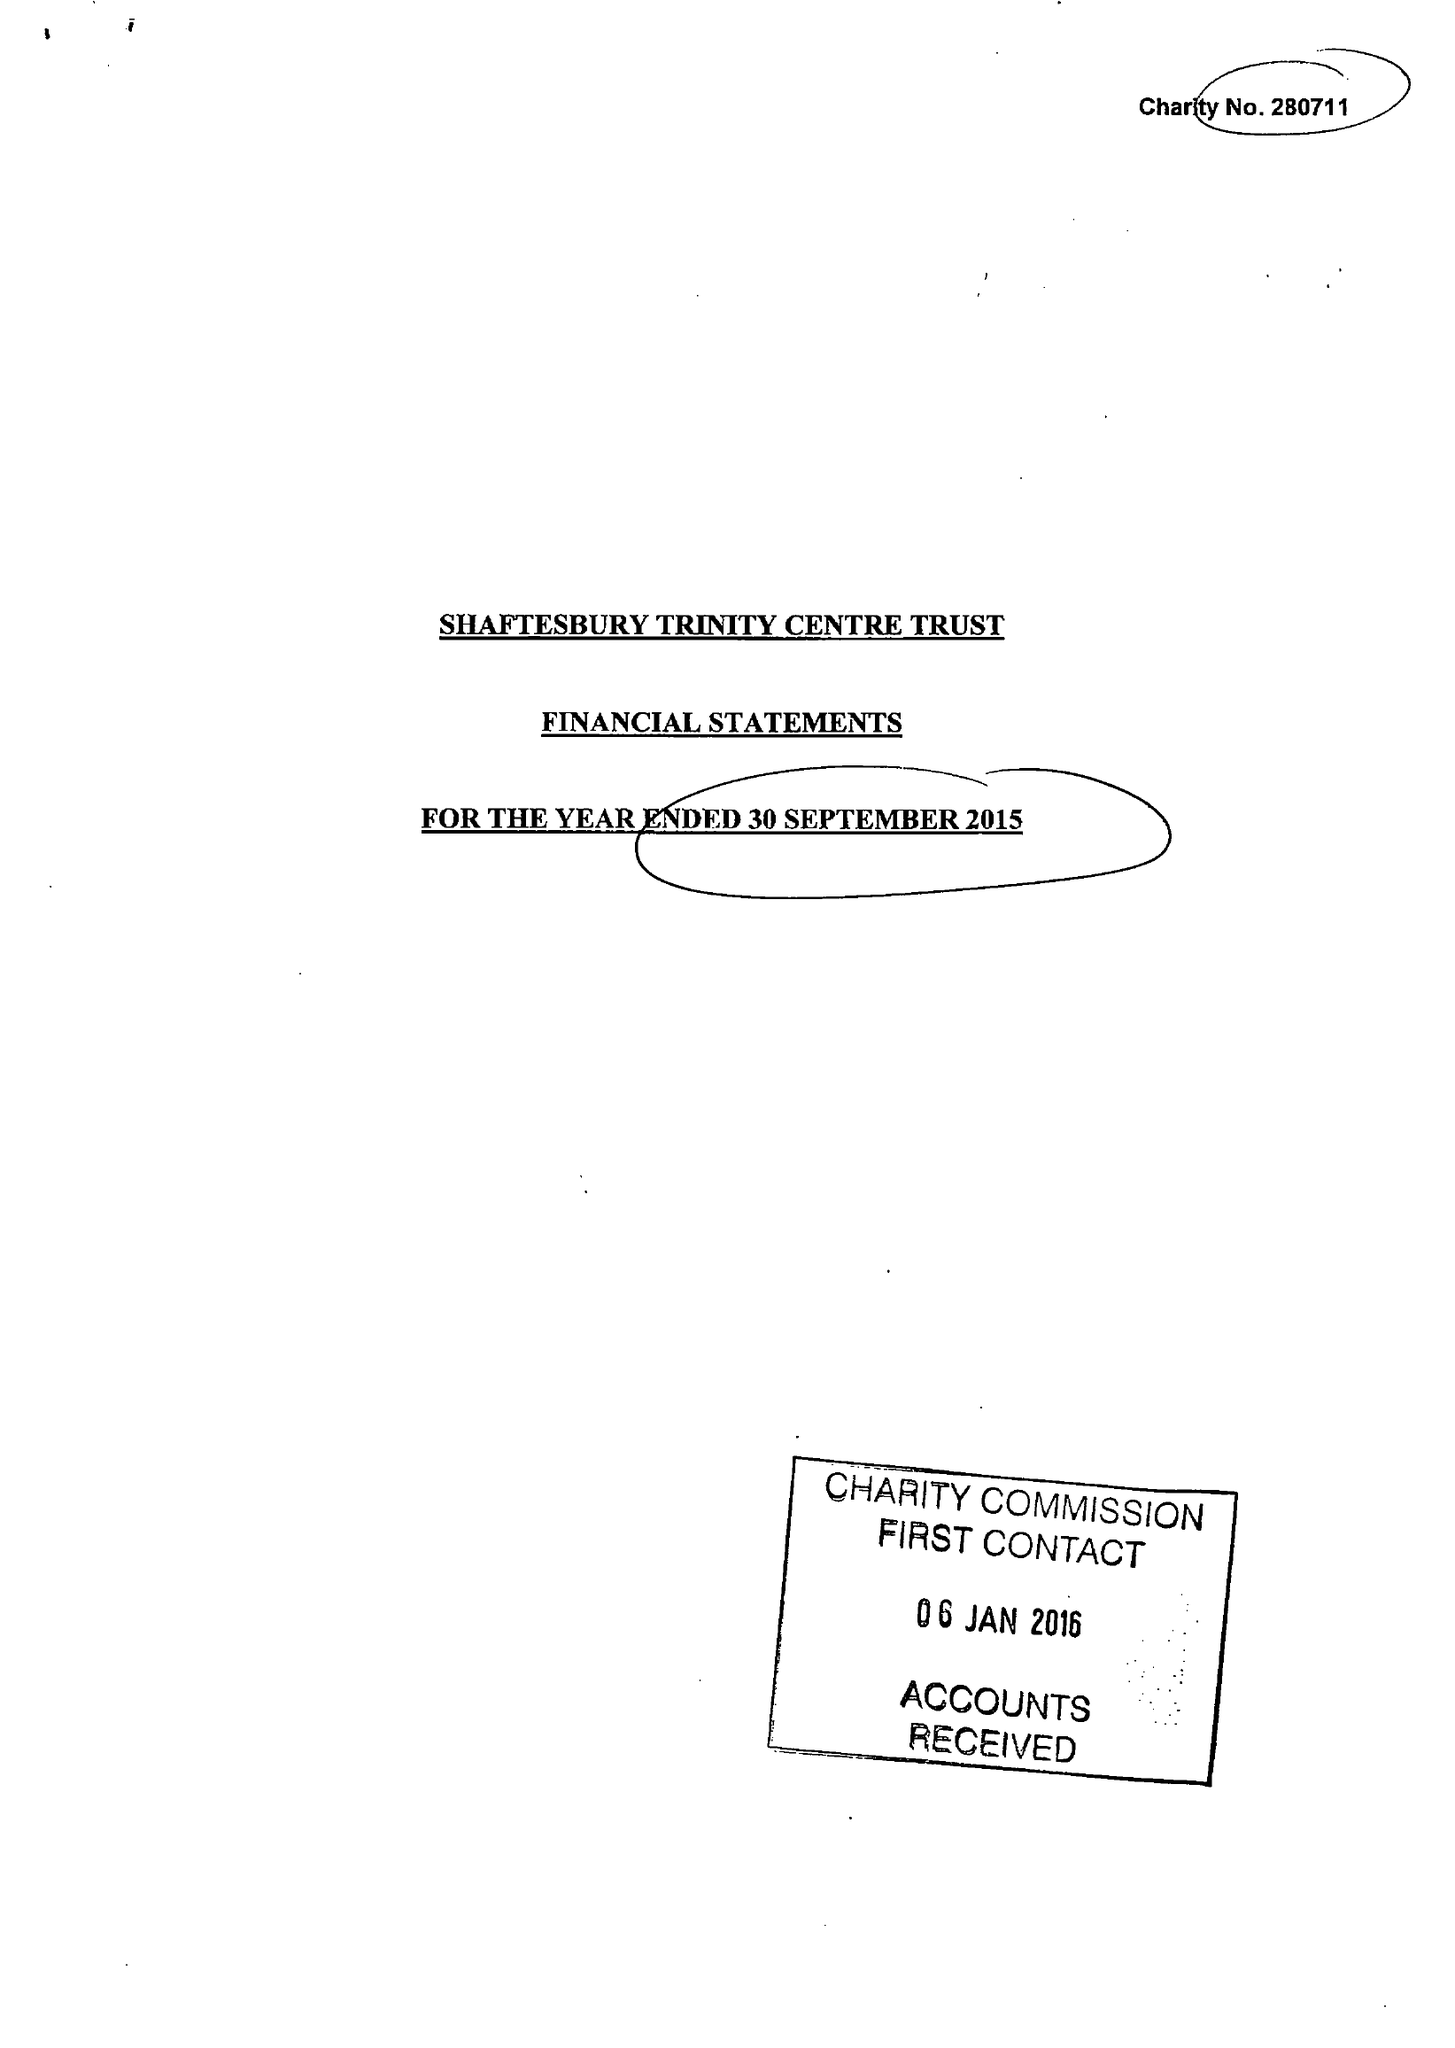What is the value for the charity_name?
Answer the question using a single word or phrase. Shaftesbury Trinity Centre Trust 